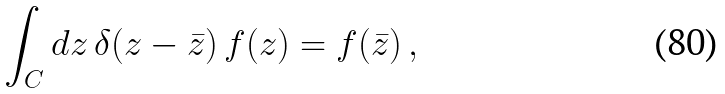<formula> <loc_0><loc_0><loc_500><loc_500>\int _ { C } d z \, \delta ( z - \bar { z } ) \, f ( z ) = f ( \bar { z } ) \, ,</formula> 